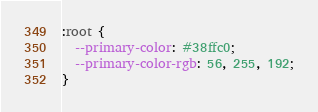Convert code to text. <code><loc_0><loc_0><loc_500><loc_500><_CSS_>:root {
  --primary-color: #38ffc0;
  --primary-color-rgb: 56, 255, 192;
}</code> 